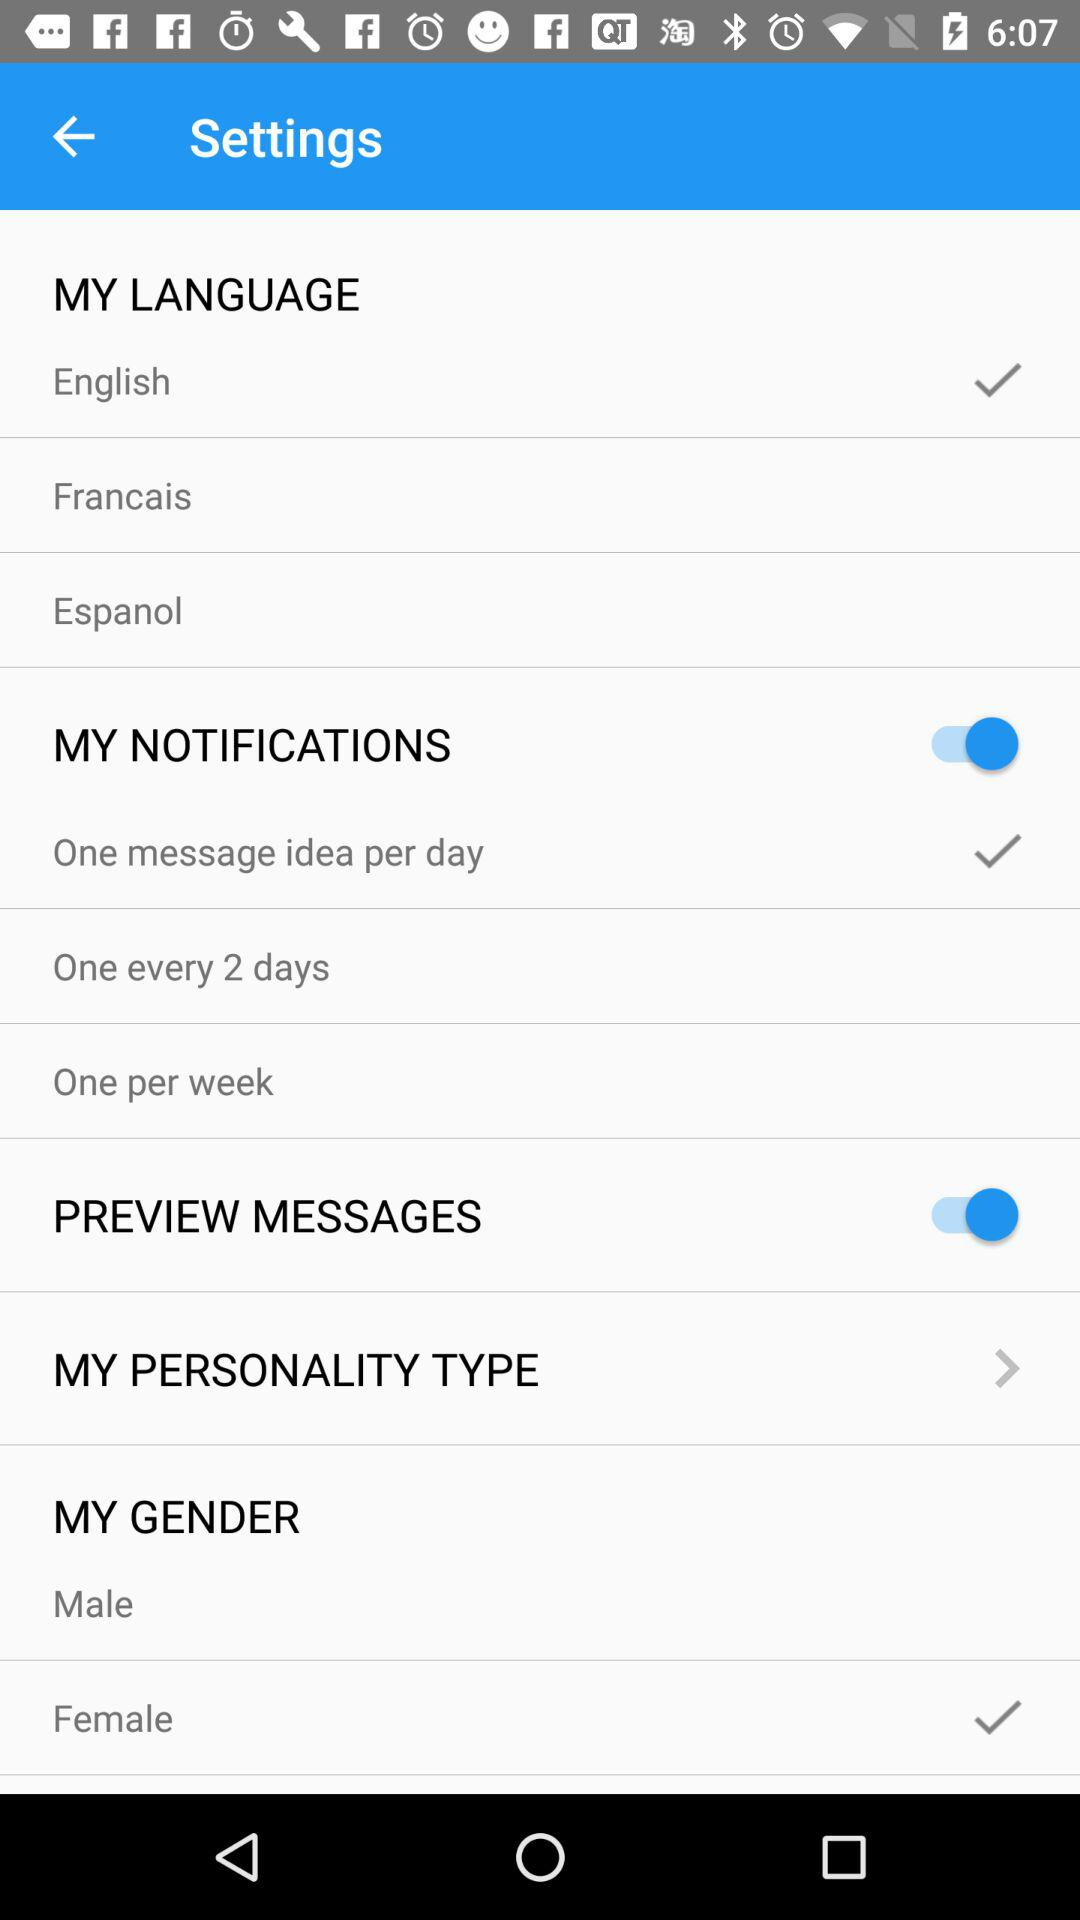How many days are available to choose from for notifications?
Answer the question using a single word or phrase. 3 